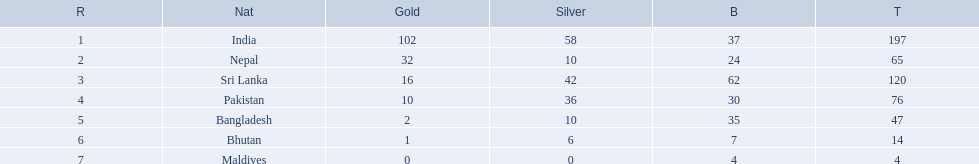What are the nations? India, Nepal, Sri Lanka, Pakistan, Bangladesh, Bhutan, Maldives. Of these, which one has earned the least amount of gold medals? Maldives. 